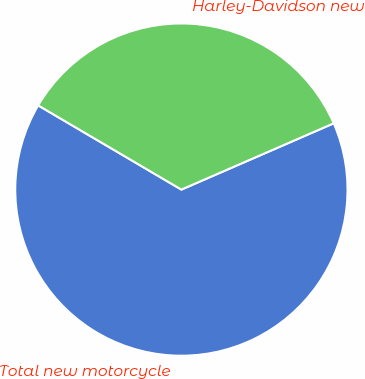<chart> <loc_0><loc_0><loc_500><loc_500><pie_chart><fcel>Total new motorcycle<fcel>Harley-Davidson new<nl><fcel>64.99%<fcel>35.01%<nl></chart> 